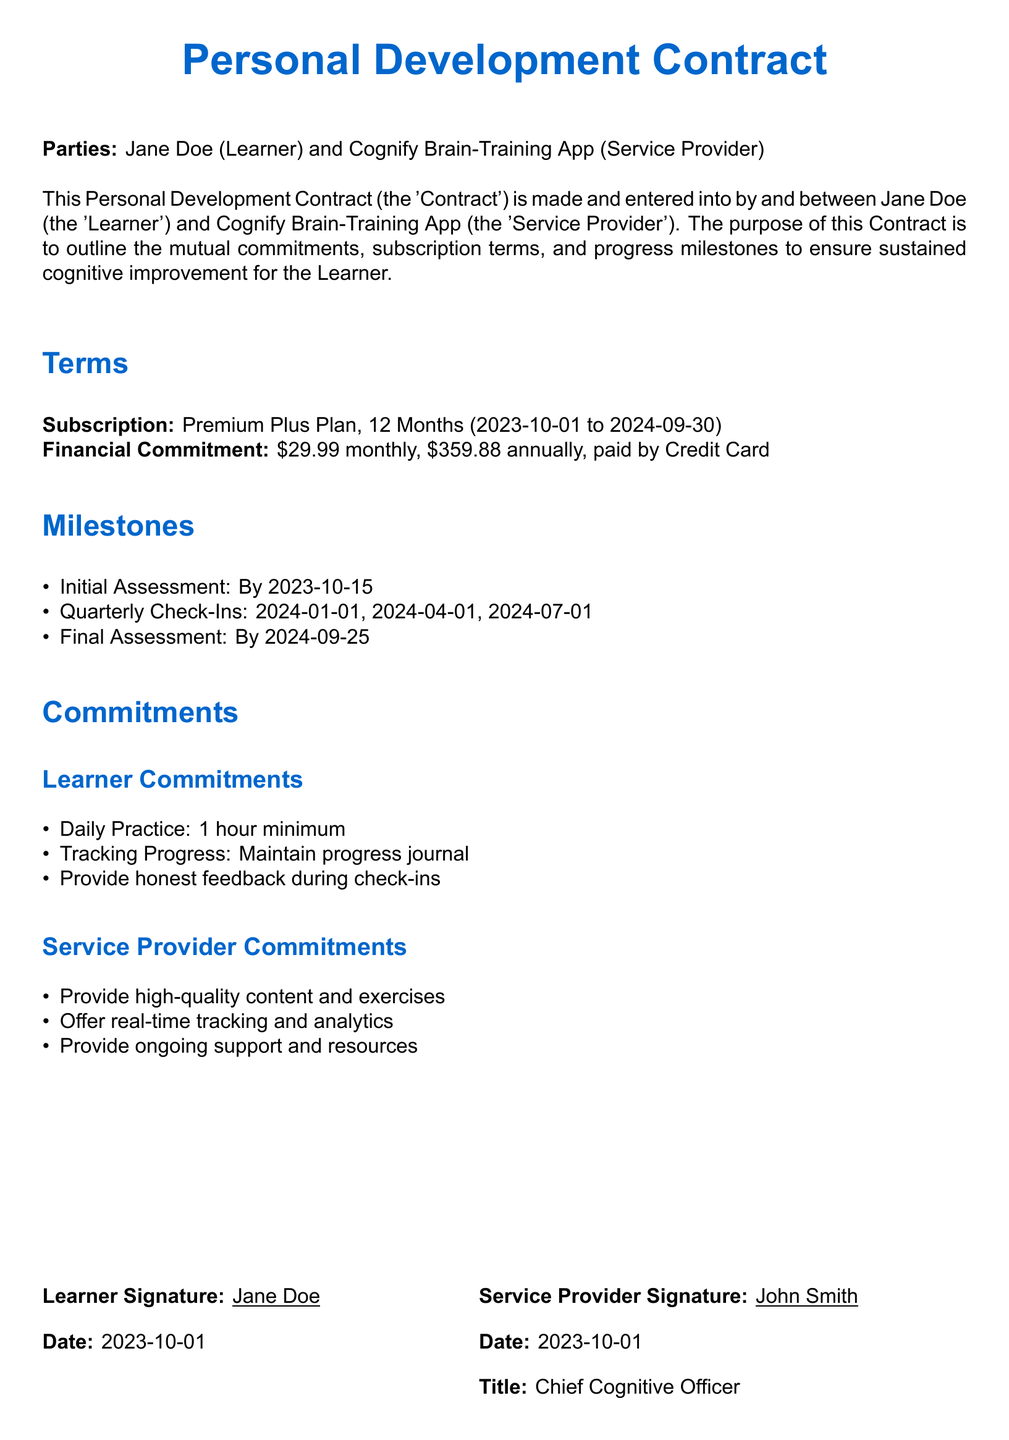What is the name of the learner? The contract specifies the name of the learner as Jane Doe.
Answer: Jane Doe Who is the service provider? The document states that the service provider is Cognify Brain-Training App.
Answer: Cognify Brain-Training App What is the start date of the subscription? The subscription starts on 2023-10-01, as indicated in the terms section.
Answer: 2023-10-01 What is the total financial commitment for the annual subscription? The document mentions the annual payment of $359.88 for the subscription plan.
Answer: $359.88 When is the final assessment scheduled? The document specifies that the final assessment is scheduled by 2024-09-25.
Answer: 2024-09-25 What is the minimum daily practice time committed by the learner? The learner commits to a minimum of 1 hour for daily practice, as stated in the commitments section.
Answer: 1 hour What type of subscription plan is being offered? The document states that the subscription plan is Premium Plus Plan.
Answer: Premium Plus Plan How many quarterly check-ins are included in the contract? The document outlines three quarterly check-ins scheduled for 2024.
Answer: Three Who signed as the service provider representative? The representative of the service provider is identified as John Smith in the signature section.
Answer: John Smith 